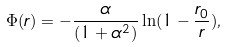Convert formula to latex. <formula><loc_0><loc_0><loc_500><loc_500>\Phi ( r ) = - \frac { \alpha } { ( 1 + \alpha ^ { 2 } ) } \ln ( 1 - \frac { r _ { 0 } } { r } ) ,</formula> 